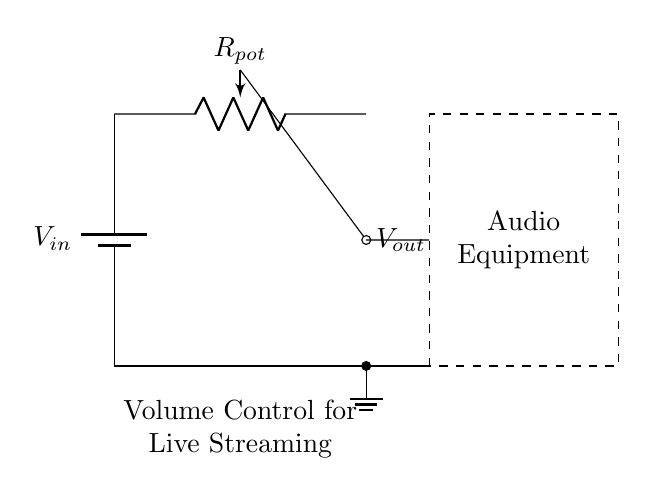What is the input voltage source labeled as? The input voltage source is labeled as V sub in, indicating it is the voltage provided to the circuit.
Answer: V in What type of component is used to control the volume? The component used to control the volume is a potentiometer, which allows for variable resistance and therefore variable voltage output.
Answer: Potentiometer What is the output voltage connected to? The output voltage, V out, is connected to audio equipment, allowing the manipulated voltage to control sound levels.
Answer: Audio Equipment What do the dashed lines represent in the circuit? The dashed lines represent the audio equipment that the potentiometer controls as part of the circuit connections.
Answer: Audio Equipment How does the wiper function in the potentiometer? The wiper of the potentiometer adjusts the resistance and hence the output voltage, affecting volume levels for the audio equipment.
Answer: Voltage adjustment What is the purpose of the ground in this circuit? The ground serves as a reference point for the voltage levels in the circuit, ensuring a common return path for electrical current.
Answer: Reference point What is the overall function of this circuit diagram? The overall function is to control the volume level in audio equipment during live streaming events through the use of a variable voltage divider.
Answer: Volume Control 